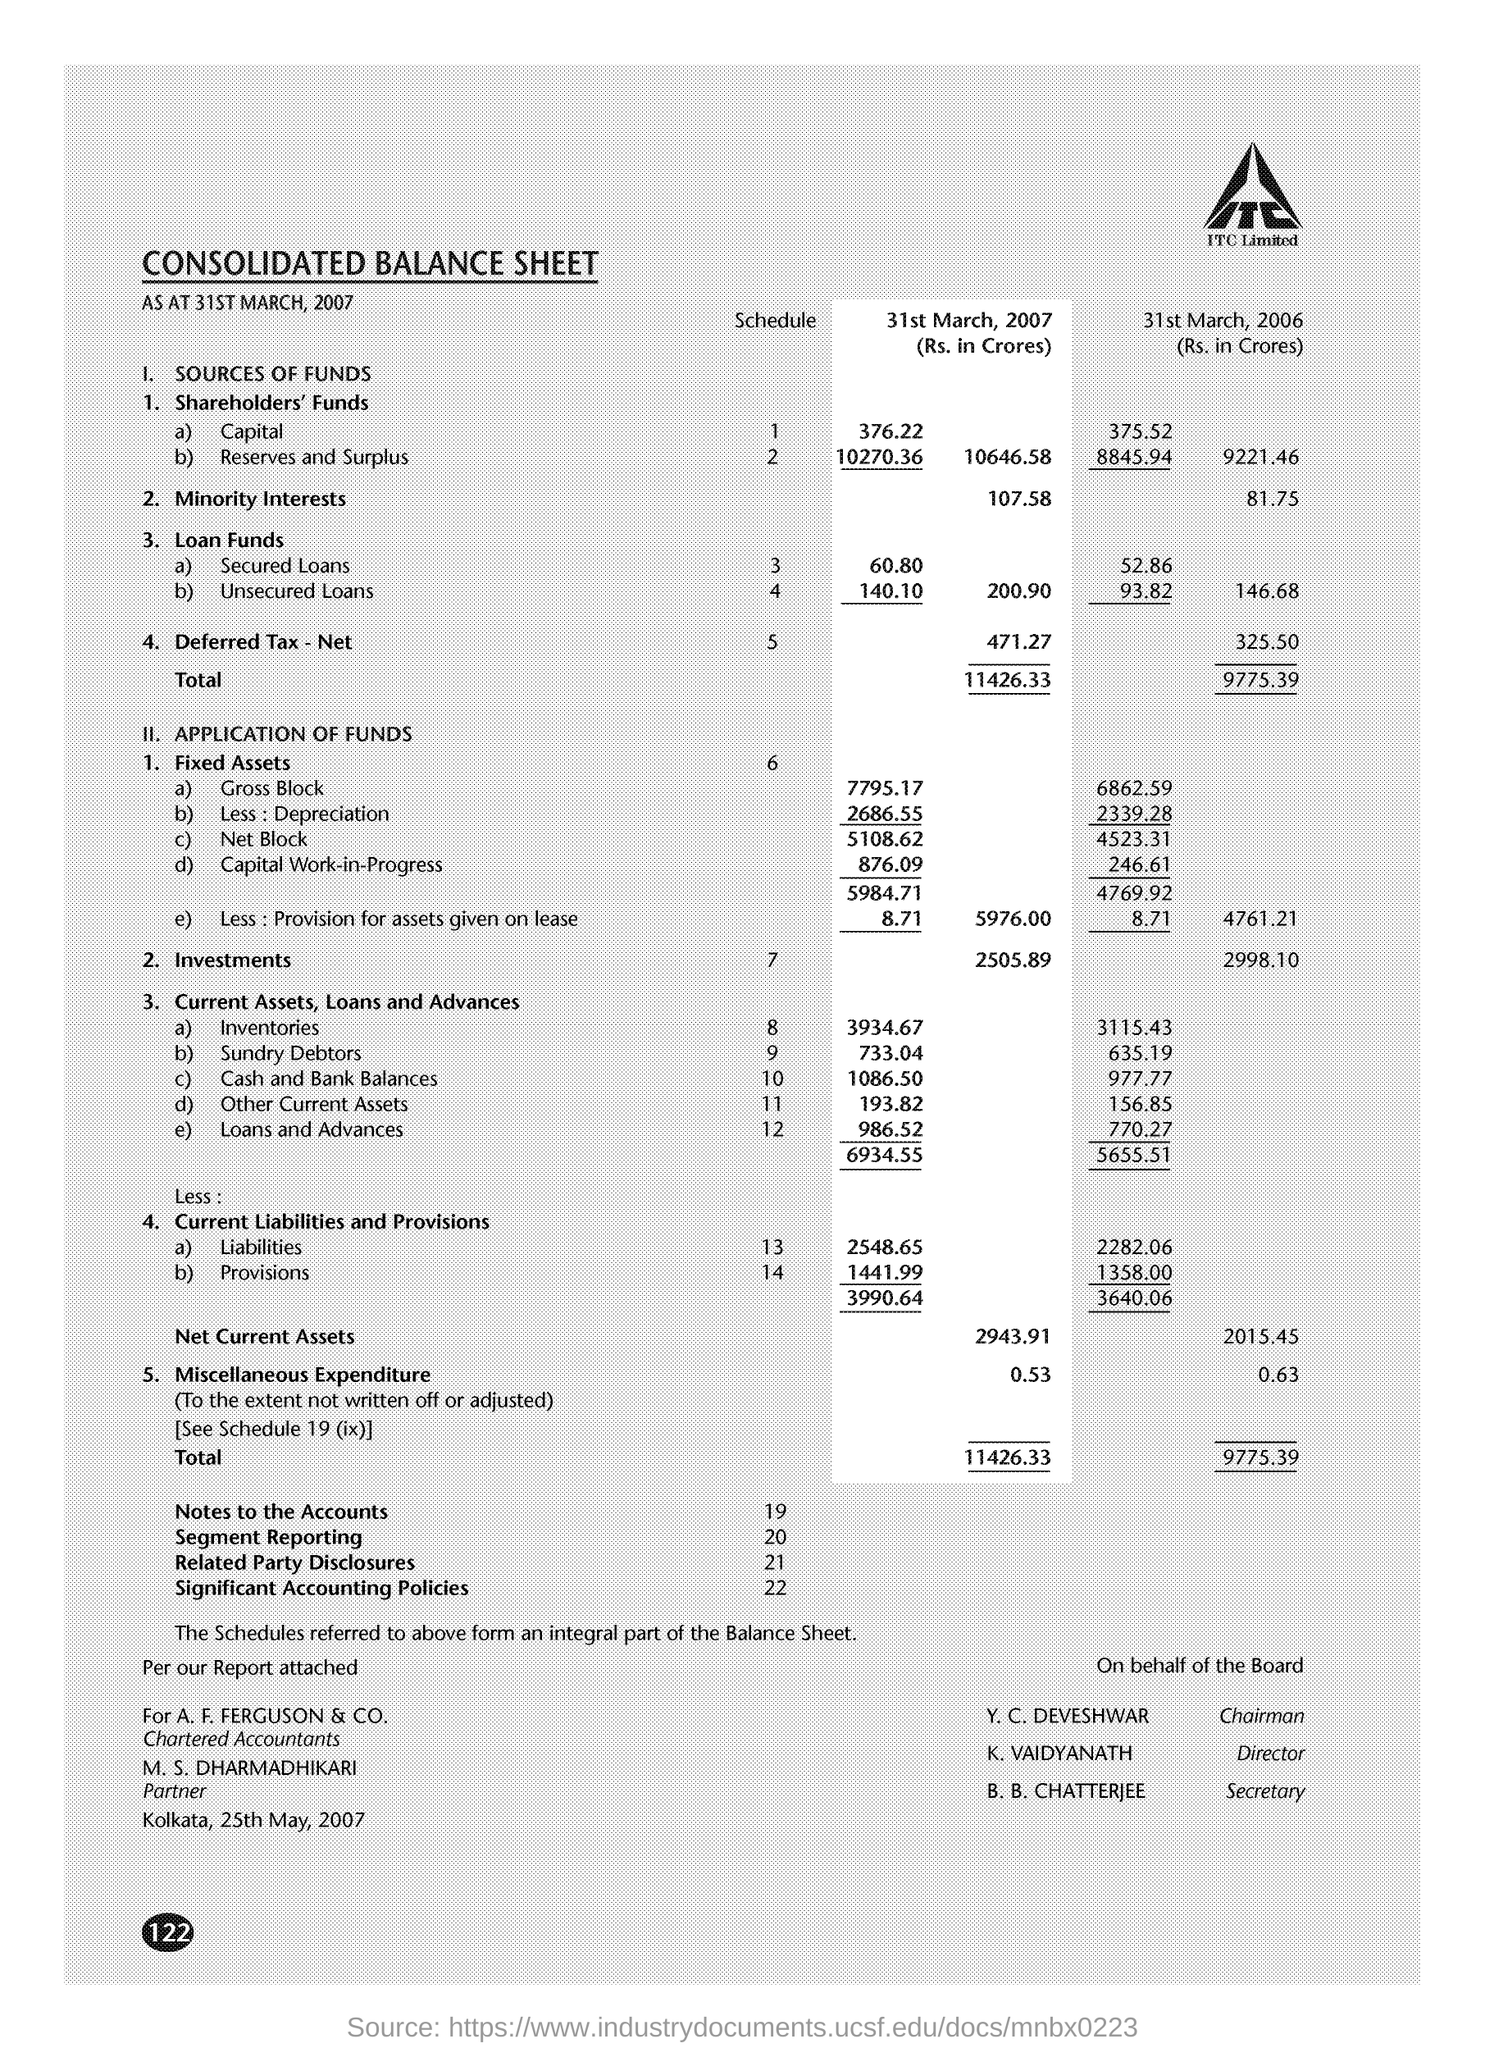What are the Net Current Assets for 31st March 2006?
 2015.45 